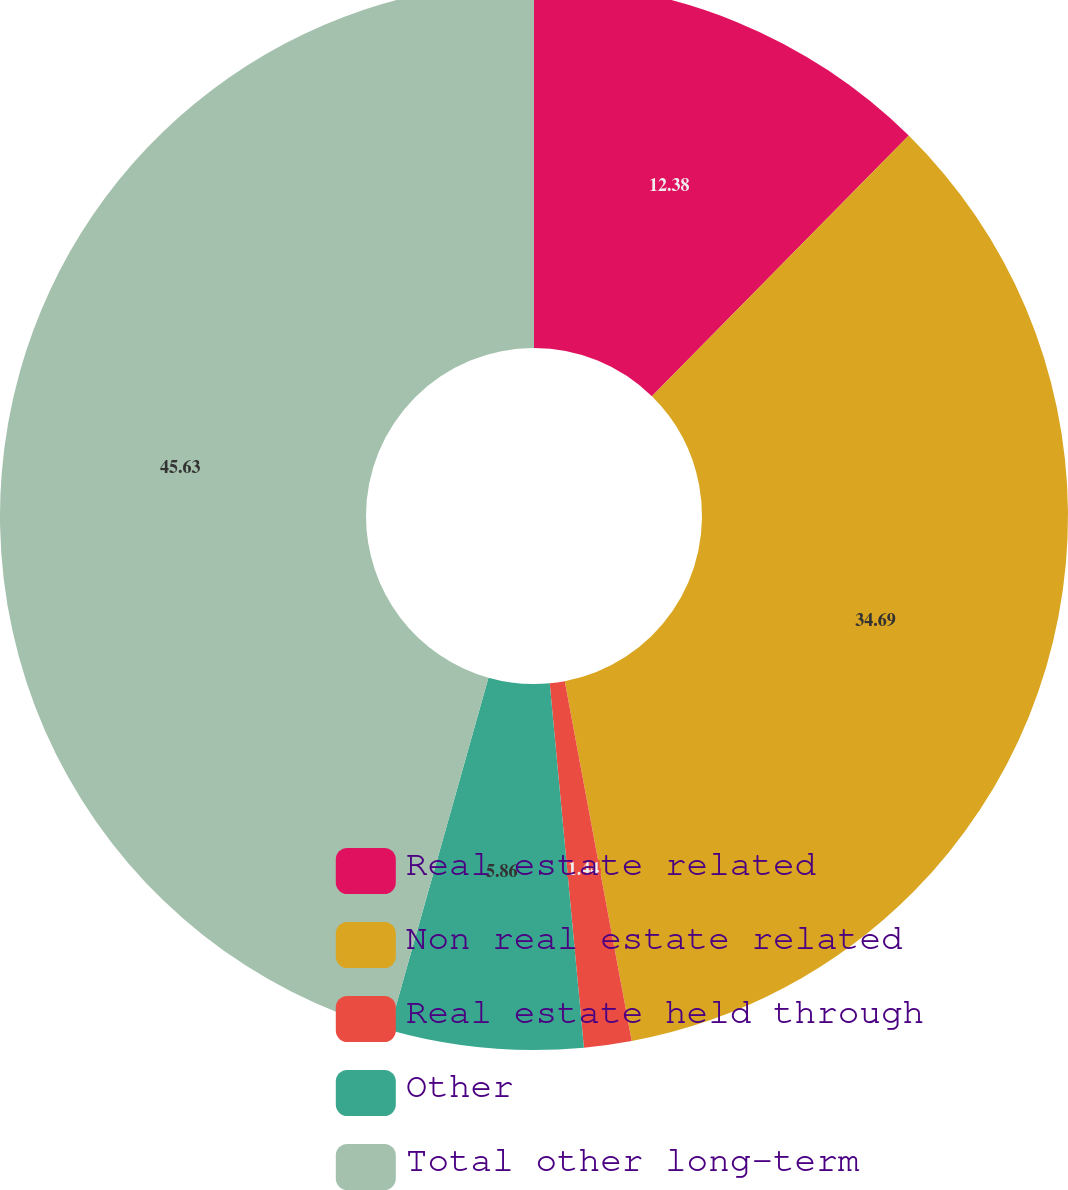Convert chart to OTSL. <chart><loc_0><loc_0><loc_500><loc_500><pie_chart><fcel>Real estate related<fcel>Non real estate related<fcel>Real estate held through<fcel>Other<fcel>Total other long-term<nl><fcel>12.38%<fcel>34.69%<fcel>1.44%<fcel>5.86%<fcel>45.63%<nl></chart> 